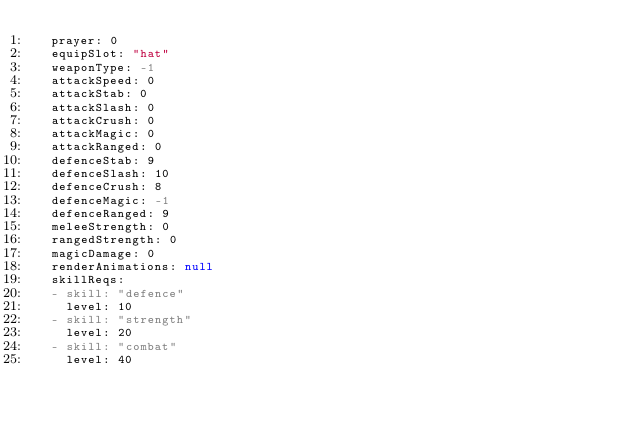Convert code to text. <code><loc_0><loc_0><loc_500><loc_500><_YAML_>  prayer: 0
  equipSlot: "hat"
  weaponType: -1
  attackSpeed: 0
  attackStab: 0
  attackSlash: 0
  attackCrush: 0
  attackMagic: 0
  attackRanged: 0
  defenceStab: 9
  defenceSlash: 10
  defenceCrush: 8
  defenceMagic: -1
  defenceRanged: 9
  meleeStrength: 0
  rangedStrength: 0
  magicDamage: 0
  renderAnimations: null
  skillReqs:
  - skill: "defence"
    level: 10
  - skill: "strength"
    level: 20
  - skill: "combat"
    level: 40
</code> 